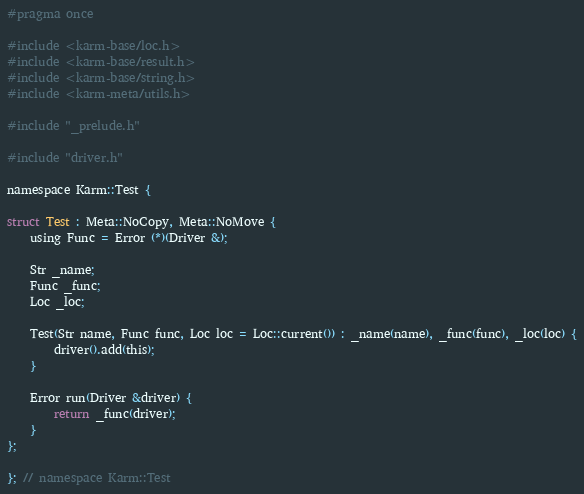Convert code to text. <code><loc_0><loc_0><loc_500><loc_500><_C_>#pragma once

#include <karm-base/loc.h>
#include <karm-base/result.h>
#include <karm-base/string.h>
#include <karm-meta/utils.h>

#include "_prelude.h"

#include "driver.h"

namespace Karm::Test {

struct Test : Meta::NoCopy, Meta::NoMove {
    using Func = Error (*)(Driver &);

    Str _name;
    Func _func;
    Loc _loc;

    Test(Str name, Func func, Loc loc = Loc::current()) : _name(name), _func(func), _loc(loc) {
        driver().add(this);
    }

    Error run(Driver &driver) {
        return _func(driver);
    }
};

}; // namespace Karm::Test
</code> 